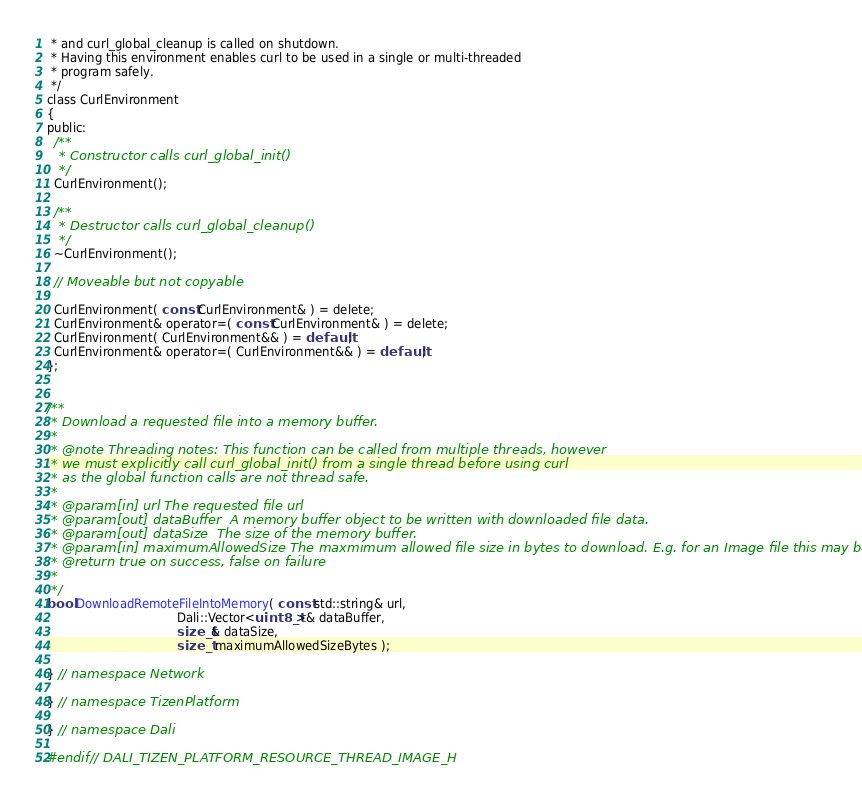<code> <loc_0><loc_0><loc_500><loc_500><_C_> * and curl_global_cleanup is called on shutdown.
 * Having this environment enables curl to be used in a single or multi-threaded
 * program safely.
 */
class CurlEnvironment
{
public:
  /**
   * Constructor calls curl_global_init()
   */
  CurlEnvironment();

  /**
   * Destructor calls curl_global_cleanup()
   */
  ~CurlEnvironment();

  // Moveable but not copyable

  CurlEnvironment( const CurlEnvironment& ) = delete;
  CurlEnvironment& operator=( const CurlEnvironment& ) = delete;
  CurlEnvironment( CurlEnvironment&& ) = default;
  CurlEnvironment& operator=( CurlEnvironment&& ) = default;
};


/**
 * Download a requested file into a memory buffer.
 *
 * @note Threading notes: This function can be called from multiple threads, however
 * we must explicitly call curl_global_init() from a single thread before using curl
 * as the global function calls are not thread safe.
 *
 * @param[in] url The requested file url
 * @param[out] dataBuffer  A memory buffer object to be written with downloaded file data.
 * @param[out] dataSize  The size of the memory buffer.
 * @param[in] maximumAllowedSize The maxmimum allowed file size in bytes to download. E.g. for an Image file this may be 50 MB
 * @return true on success, false on failure
 *
 */
bool DownloadRemoteFileIntoMemory( const std::string& url,
                                   Dali::Vector<uint8_t>& dataBuffer,
                                   size_t& dataSize,
                                   size_t maximumAllowedSizeBytes );

} // namespace Network

} // namespace TizenPlatform

} // namespace Dali

#endif // DALI_TIZEN_PLATFORM_RESOURCE_THREAD_IMAGE_H
</code> 